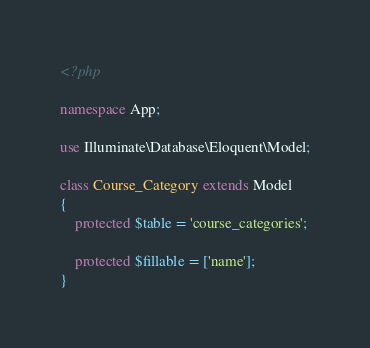Convert code to text. <code><loc_0><loc_0><loc_500><loc_500><_PHP_><?php

namespace App;

use Illuminate\Database\Eloquent\Model;

class Course_Category extends Model
{
	protected $table = 'course_categories';

	protected $fillable = ['name'];
}
</code> 